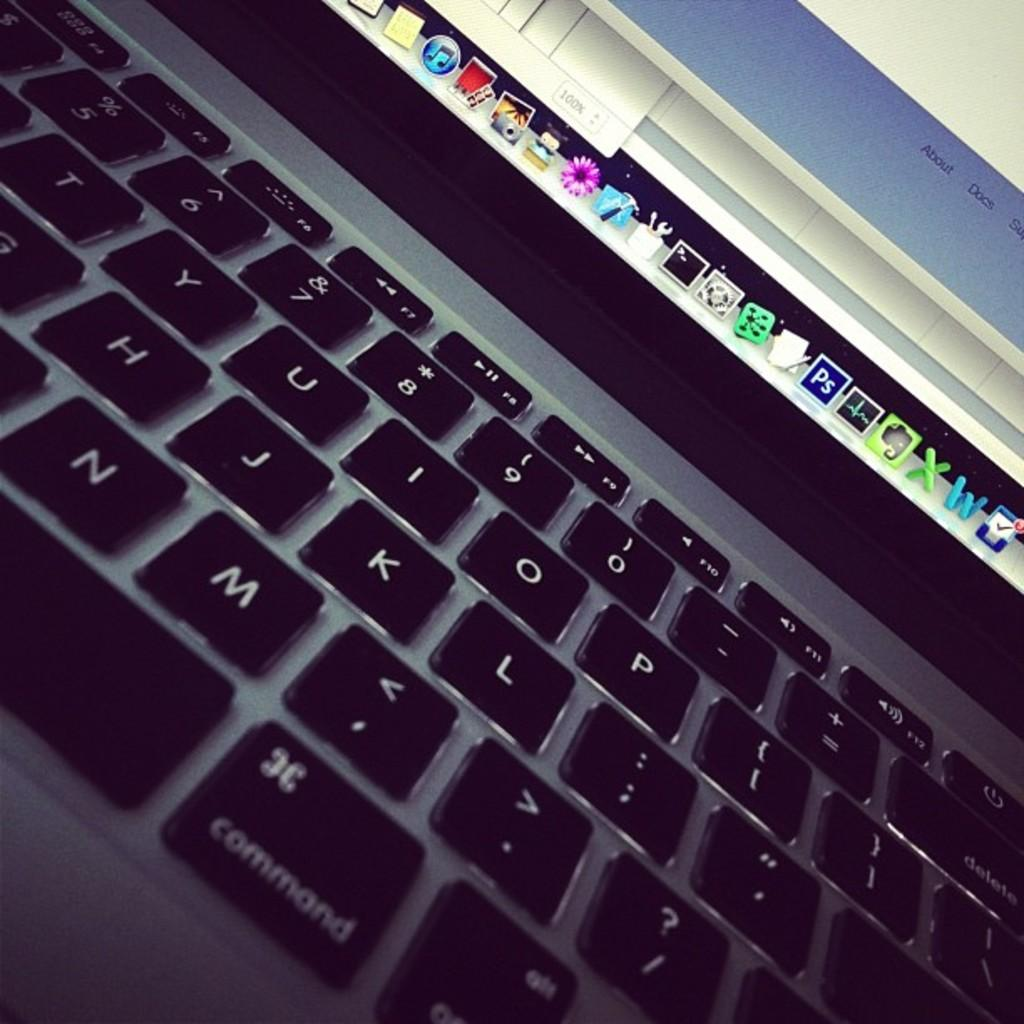Provide a one-sentence caption for the provided image. The keyboard of a laptop includes a command button. 